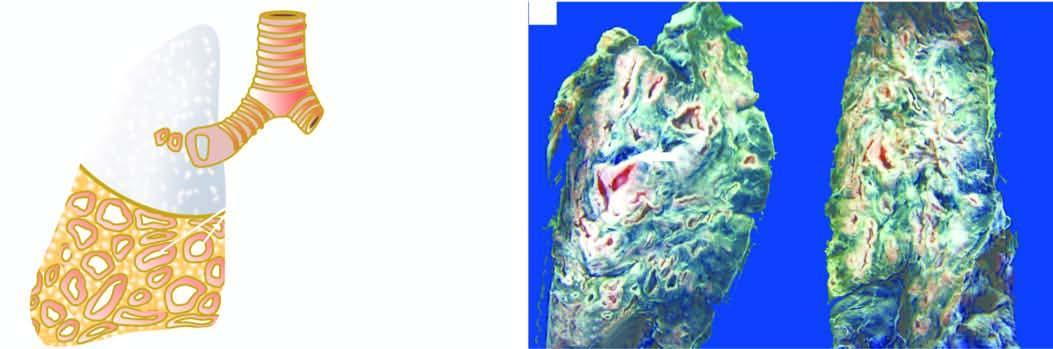what are many thick-walled dilated cavities with?
Answer the question using a single word or phrase. Cartilaginous wall 